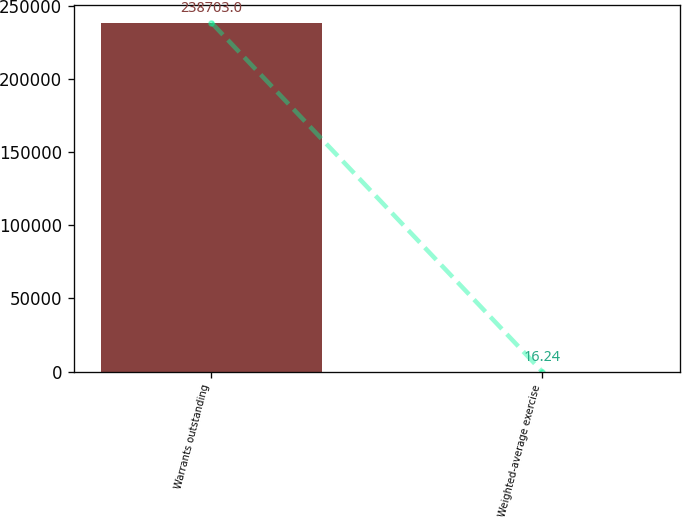Convert chart to OTSL. <chart><loc_0><loc_0><loc_500><loc_500><bar_chart><fcel>Warrants outstanding<fcel>Weighted-average exercise<nl><fcel>238703<fcel>16.24<nl></chart> 